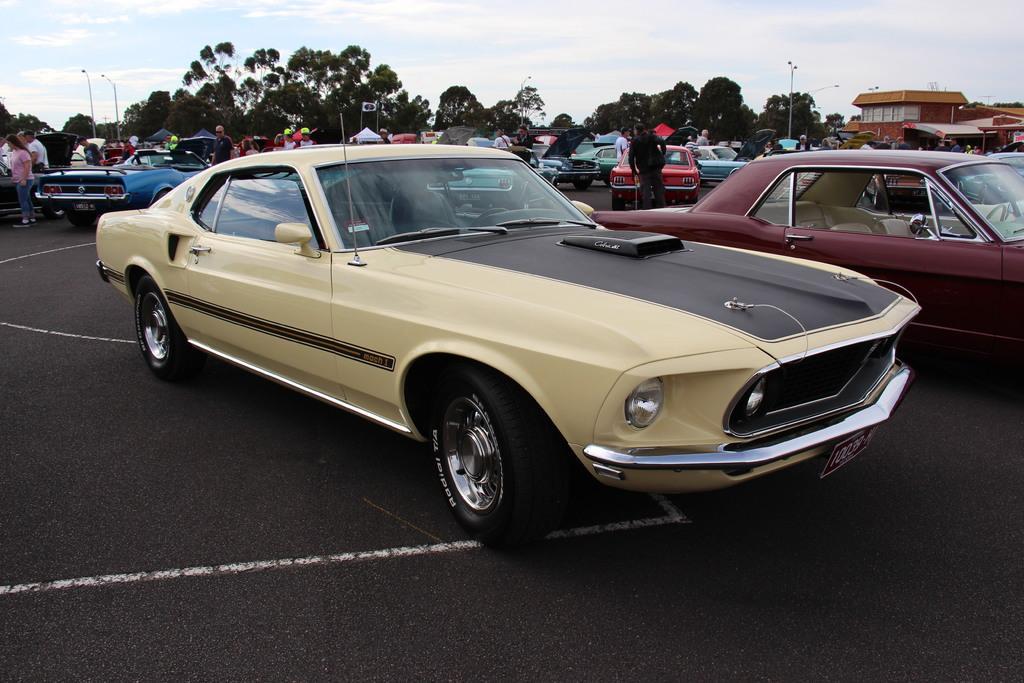Please provide a concise description of this image. In this image, we can see a car is parked on the road. Background we can see vehicles, people, stalls, building, street lights, trees and sky. 